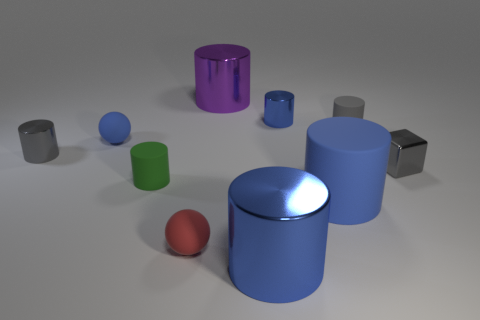Subtract all gray cylinders. How many cylinders are left? 5 Subtract all red cubes. How many gray cylinders are left? 2 Subtract 6 cylinders. How many cylinders are left? 1 Subtract all gray cylinders. How many cylinders are left? 5 Subtract all blocks. How many objects are left? 9 Add 5 big yellow cylinders. How many big yellow cylinders exist? 5 Subtract 0 cyan cubes. How many objects are left? 10 Subtract all purple blocks. Subtract all red cylinders. How many blocks are left? 1 Subtract all purple cylinders. Subtract all tiny gray blocks. How many objects are left? 8 Add 1 red things. How many red things are left? 2 